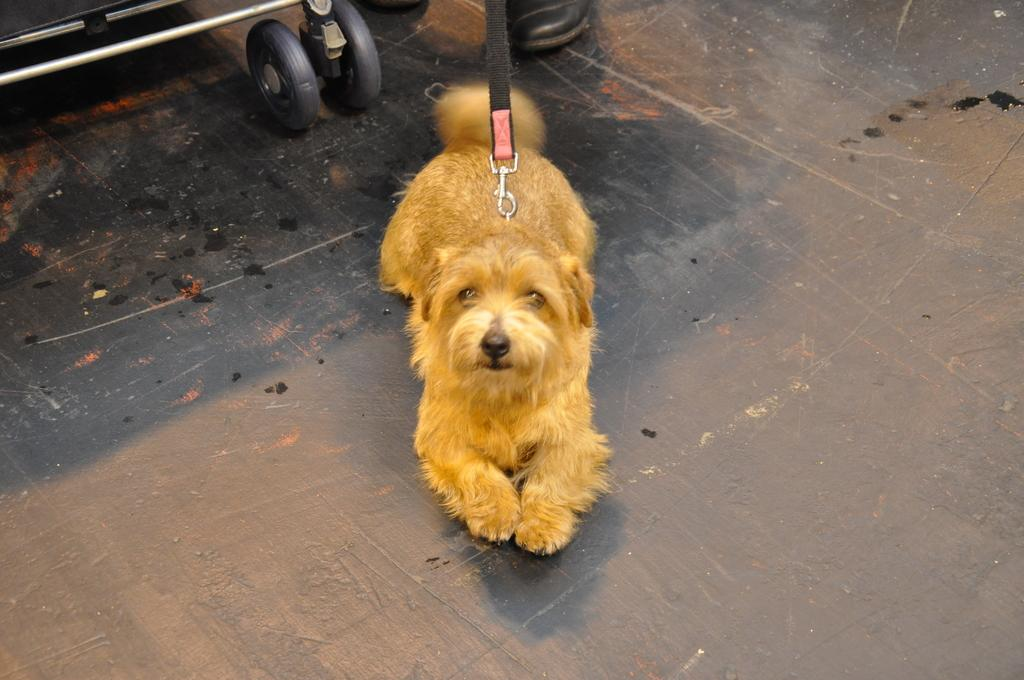What type of animal is in the picture? There is a dog in the picture. Where is the dog located in the image? The dog is sitting on the floor in the middle of the picture. What is the color of the dog? The dog is brown in color. What type of guitar is the dog playing in the image? There is no guitar present in the image; it features a dog sitting on the floor. 